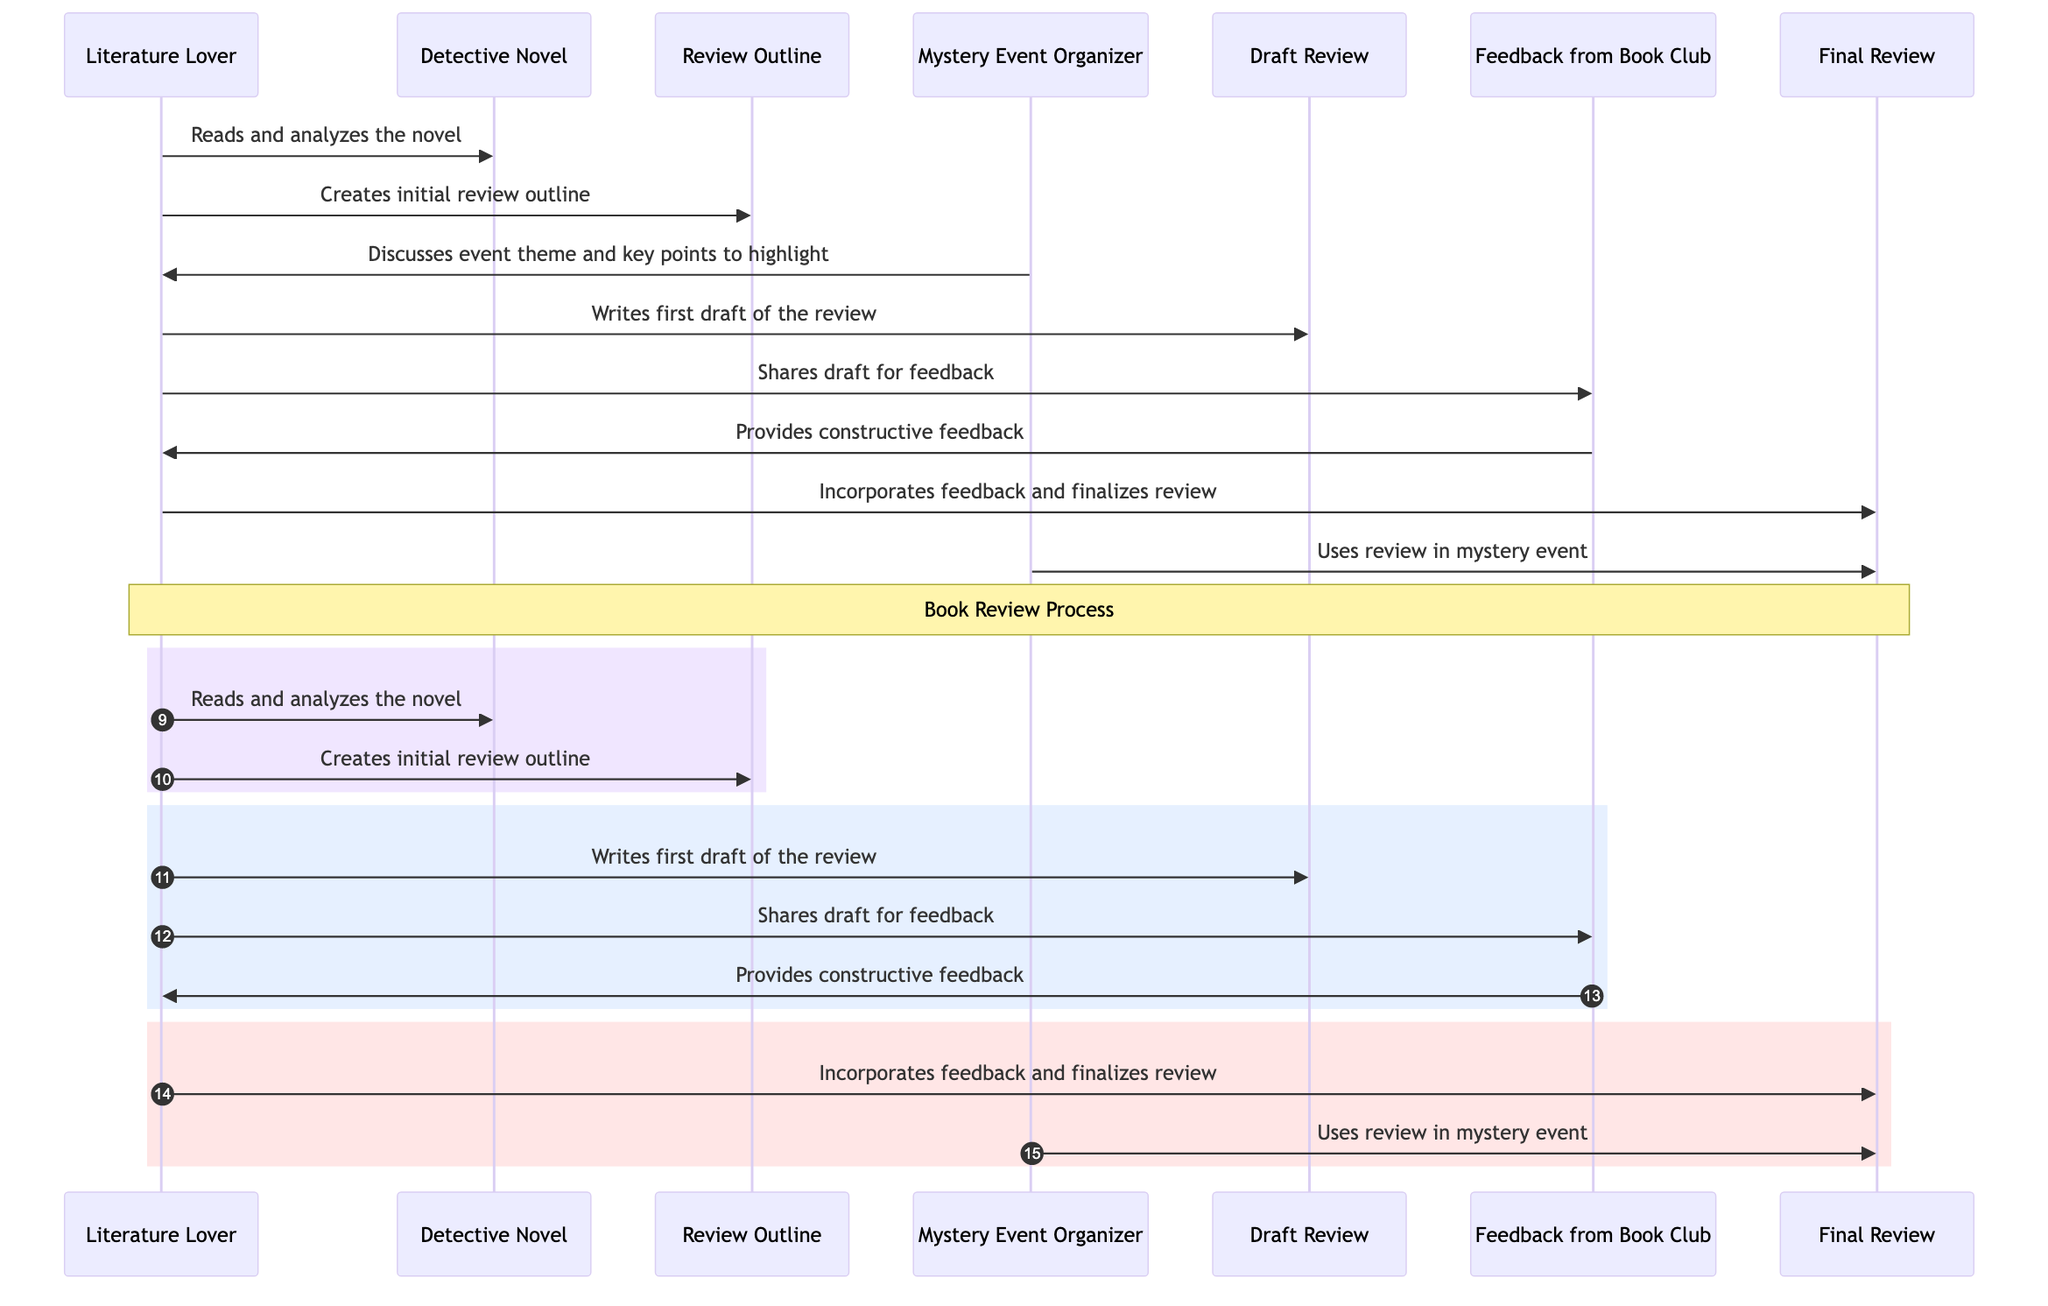What is the first action taken by the Literature Lover? The Literature Lover's first action is to read and analyze the detective novel. This is evidenced by the first message in the sequence diagram where the Literature Lover sends a message to the Detective Novel.
Answer: Reads and analyzes the novel How many participants are in the diagram? The diagram lists seven participants: Literature Lover, Mystery Event Organizer, Book Reviewer, Detective Novel, Review Outline, Draft Review, Feedback from Book Club, and Final Review. By counting each unique participant, we find the total.
Answer: Seven What comes after creating the initial review outline? After creating the initial review outline, the next action taken by the Literature Lover is to write the first draft of the review, as indicated by the sequence in the diagram.
Answer: Writes first draft of the review Which entity provides feedback to the Literature Lover? The Feedback from Book Club provides feedback to the Literature Lover, as shown by the directed message from Feedback from Book Club back to the Literature Lover.
Answer: Feedback from Book Club What is the last action taken by the Mystery Event Organizer in the sequence? The last action taken by the Mystery Event Organizer is to use the final review in the mystery event. This can be traced from the last message directed from the Mystery Event Organizer to the Final Review.
Answer: Uses review in mystery event What is the role of the Review Outline in the process? The Review Outline is created by the Literature Lover to outline the review. This is confirmed by the message connection from the Literature Lover to the Review Outline, indicating its creation as a helpful step in the review process.
Answer: Creates initial review outline How many steps are taken to finalize the review? There are two main steps to finalize the review: incorporating feedback and finalizing the review, as observed by two sequential messages directed towards the Final Review.
Answer: Two What is the purpose of the constructive feedback? The purpose of the constructive feedback is to help the Literature Lover improve the draft review before it is finalized, ensuring the review is polished and addresses any areas that may need improvement. This is evident from the dialogue about sharing the draft for feedback.
Answer: Improve the draft review 